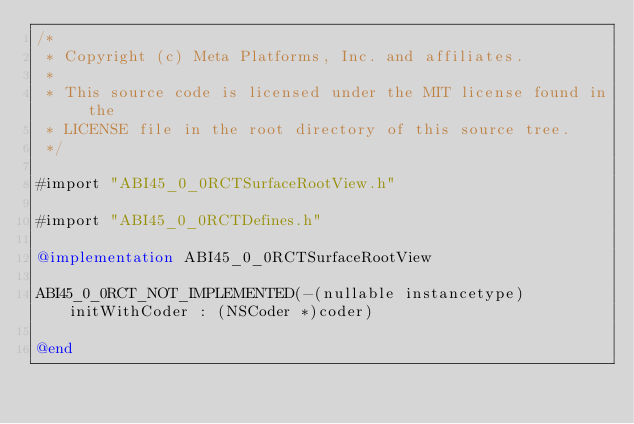<code> <loc_0><loc_0><loc_500><loc_500><_ObjectiveC_>/*
 * Copyright (c) Meta Platforms, Inc. and affiliates.
 *
 * This source code is licensed under the MIT license found in the
 * LICENSE file in the root directory of this source tree.
 */

#import "ABI45_0_0RCTSurfaceRootView.h"

#import "ABI45_0_0RCTDefines.h"

@implementation ABI45_0_0RCTSurfaceRootView

ABI45_0_0RCT_NOT_IMPLEMENTED(-(nullable instancetype)initWithCoder : (NSCoder *)coder)

@end
</code> 